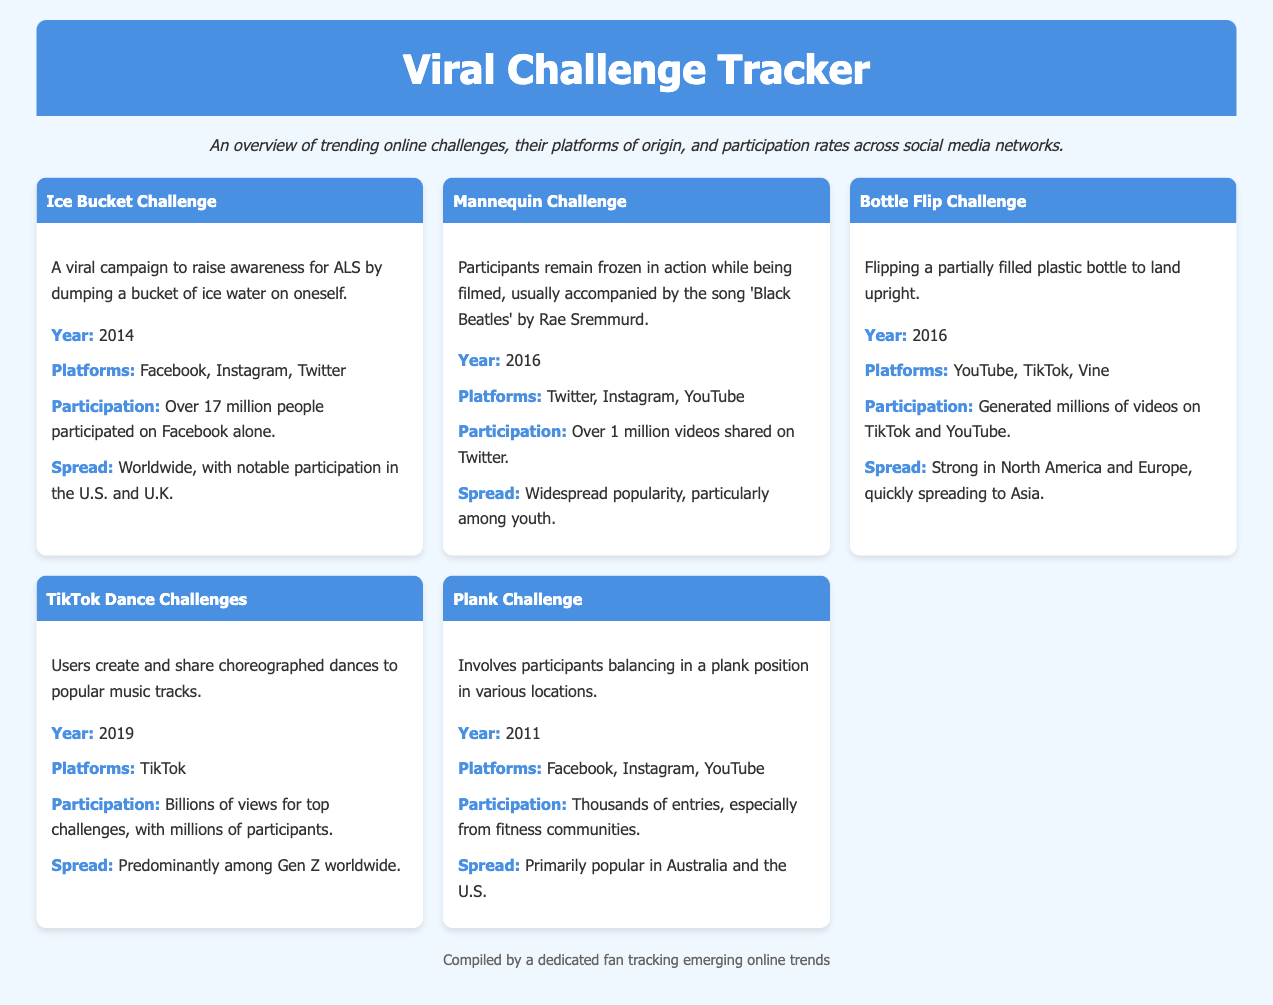What year was the Ice Bucket Challenge initiated? The document states that the Ice Bucket Challenge took place in 2014.
Answer: 2014 Which platform saw over 17 million participants for the Ice Bucket Challenge? The document mentions that over 17 million people participated on Facebook alone for the Ice Bucket Challenge.
Answer: Facebook What is a notable aspect of the Mannequin Challenge? The Mannequin Challenge is characterized by participants remaining frozen in action while being filmed.
Answer: Frozen in action In which year did the TikTok Dance Challenges rise to popularity? According to the document, TikTok Dance Challenges began in 2019.
Answer: 2019 How many videos were shared for the Mannequin Challenge on Twitter? The document specifies that over 1 million videos were shared on Twitter for the Mannequin Challenge.
Answer: Over 1 million Which challenge primarily spread among Gen Z worldwide? The document states that TikTok Dance Challenges were predominantly popular among Gen Z.
Answer: TikTok Dance Challenges What is the participation trend for the Bottle Flip Challenge? The Bottle Flip Challenge led to millions of videos generated on TikTok and YouTube, indicating a high participation trend.
Answer: Millions of videos What platform was the Plank Challenge predominantly popular on? The document indicates that the Plank Challenge was popular on Facebook, Instagram, and YouTube.
Answer: Facebook, Instagram, YouTube Which challenge is known for raising awareness for ALS? The Ice Bucket Challenge is specifically noted for raising awareness for ALS.
Answer: Ice Bucket Challenge 